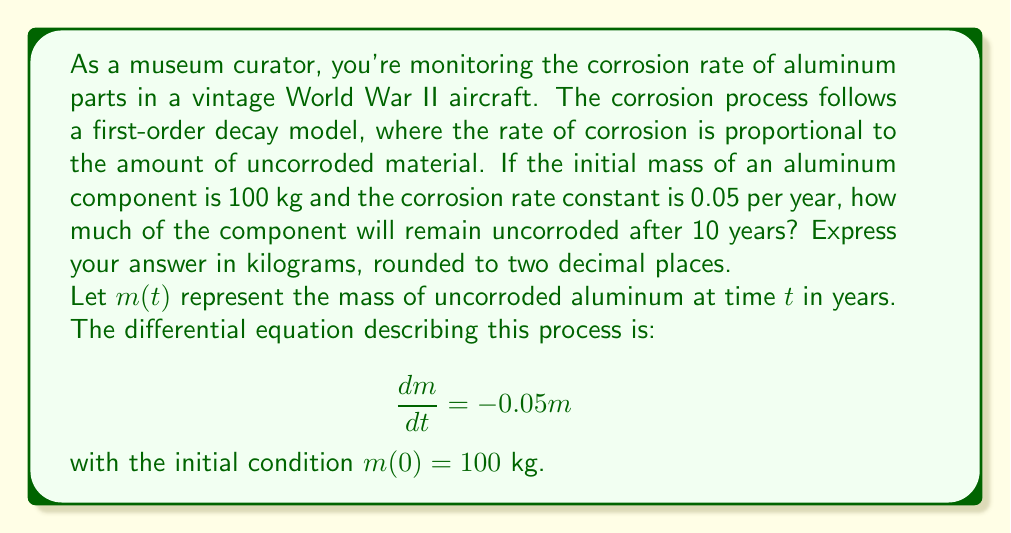Provide a solution to this math problem. To solve this problem, we need to use the given first-order differential equation and its initial condition.

1) The general solution to the differential equation $\frac{dm}{dt} = -km$ is:

   $m(t) = Ce^{-kt}$

   where $C$ is a constant and $k$ is the decay rate.

2) In this case, $k = 0.05$ per year. We can find $C$ using the initial condition:

   $m(0) = 100 = Ce^{-0.05 \cdot 0} = C$

3) Therefore, the specific solution for our problem is:

   $m(t) = 100e^{-0.05t}$

4) To find the mass after 10 years, we evaluate $m(10)$:

   $m(10) = 100e^{-0.05 \cdot 10}$
   
   $= 100e^{-0.5}$
   
   $= 100 \cdot 0.6065$
   
   $= 60.65$ kg

5) Rounding to two decimal places, we get 60.65 kg.
Answer: 60.65 kg 